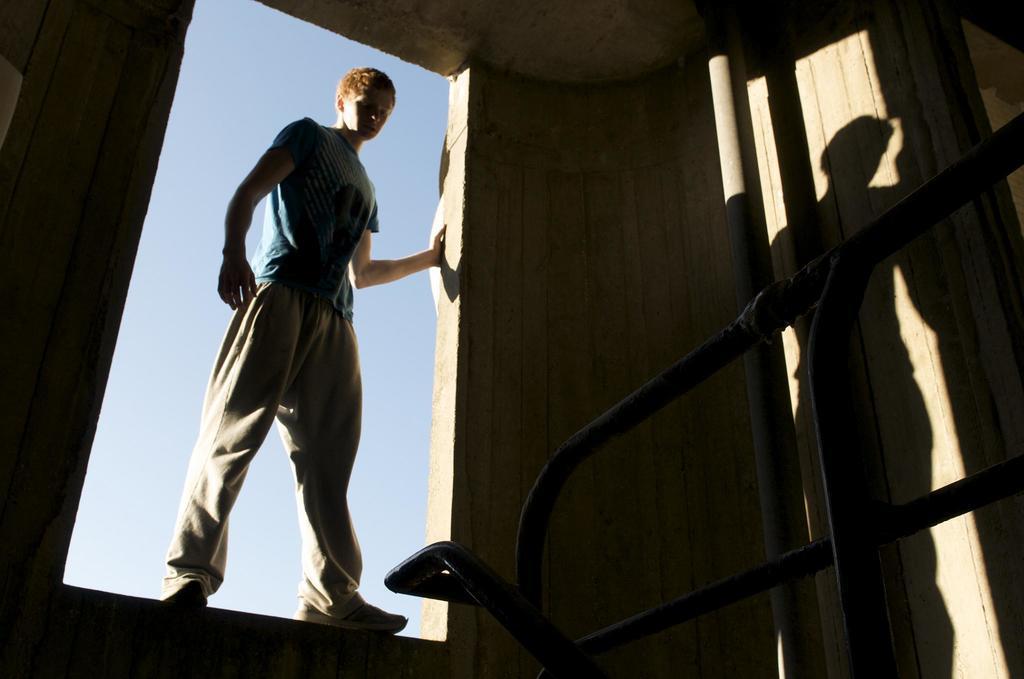Please provide a concise description of this image. Here we can see a person and this is wall. There is a pole. In the background there is sky. 